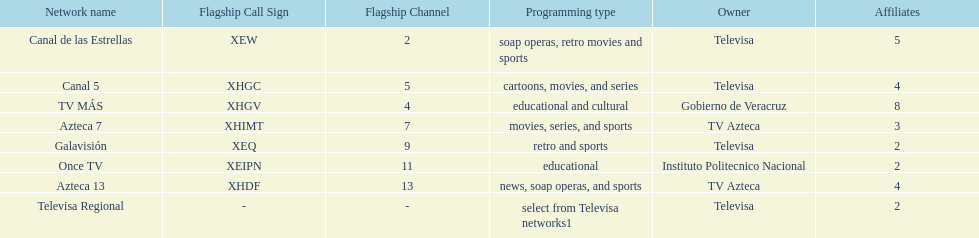Tell me the number of stations tv azteca owns. 2. 